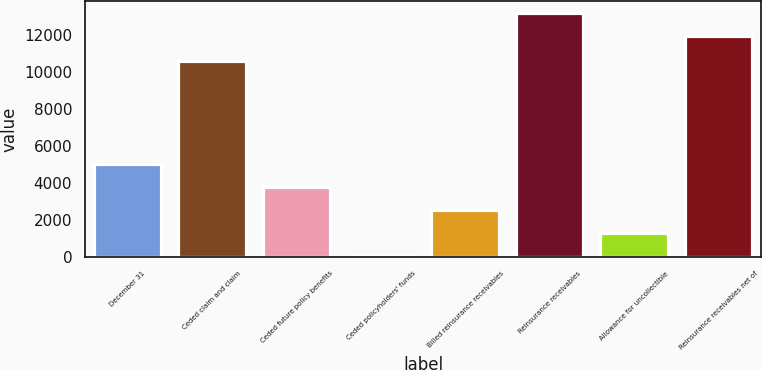<chart> <loc_0><loc_0><loc_500><loc_500><bar_chart><fcel>December 31<fcel>Ceded claim and claim<fcel>Ceded future policy benefits<fcel>Ceded policyholders' funds<fcel>Billed reinsurance receivables<fcel>Reinsurance receivables<fcel>Allowance for uncollectible<fcel>Reinsurance receivables net of<nl><fcel>5008.46<fcel>10605.2<fcel>3770.42<fcel>56.3<fcel>2532.38<fcel>13155.4<fcel>1294.34<fcel>11917.4<nl></chart> 